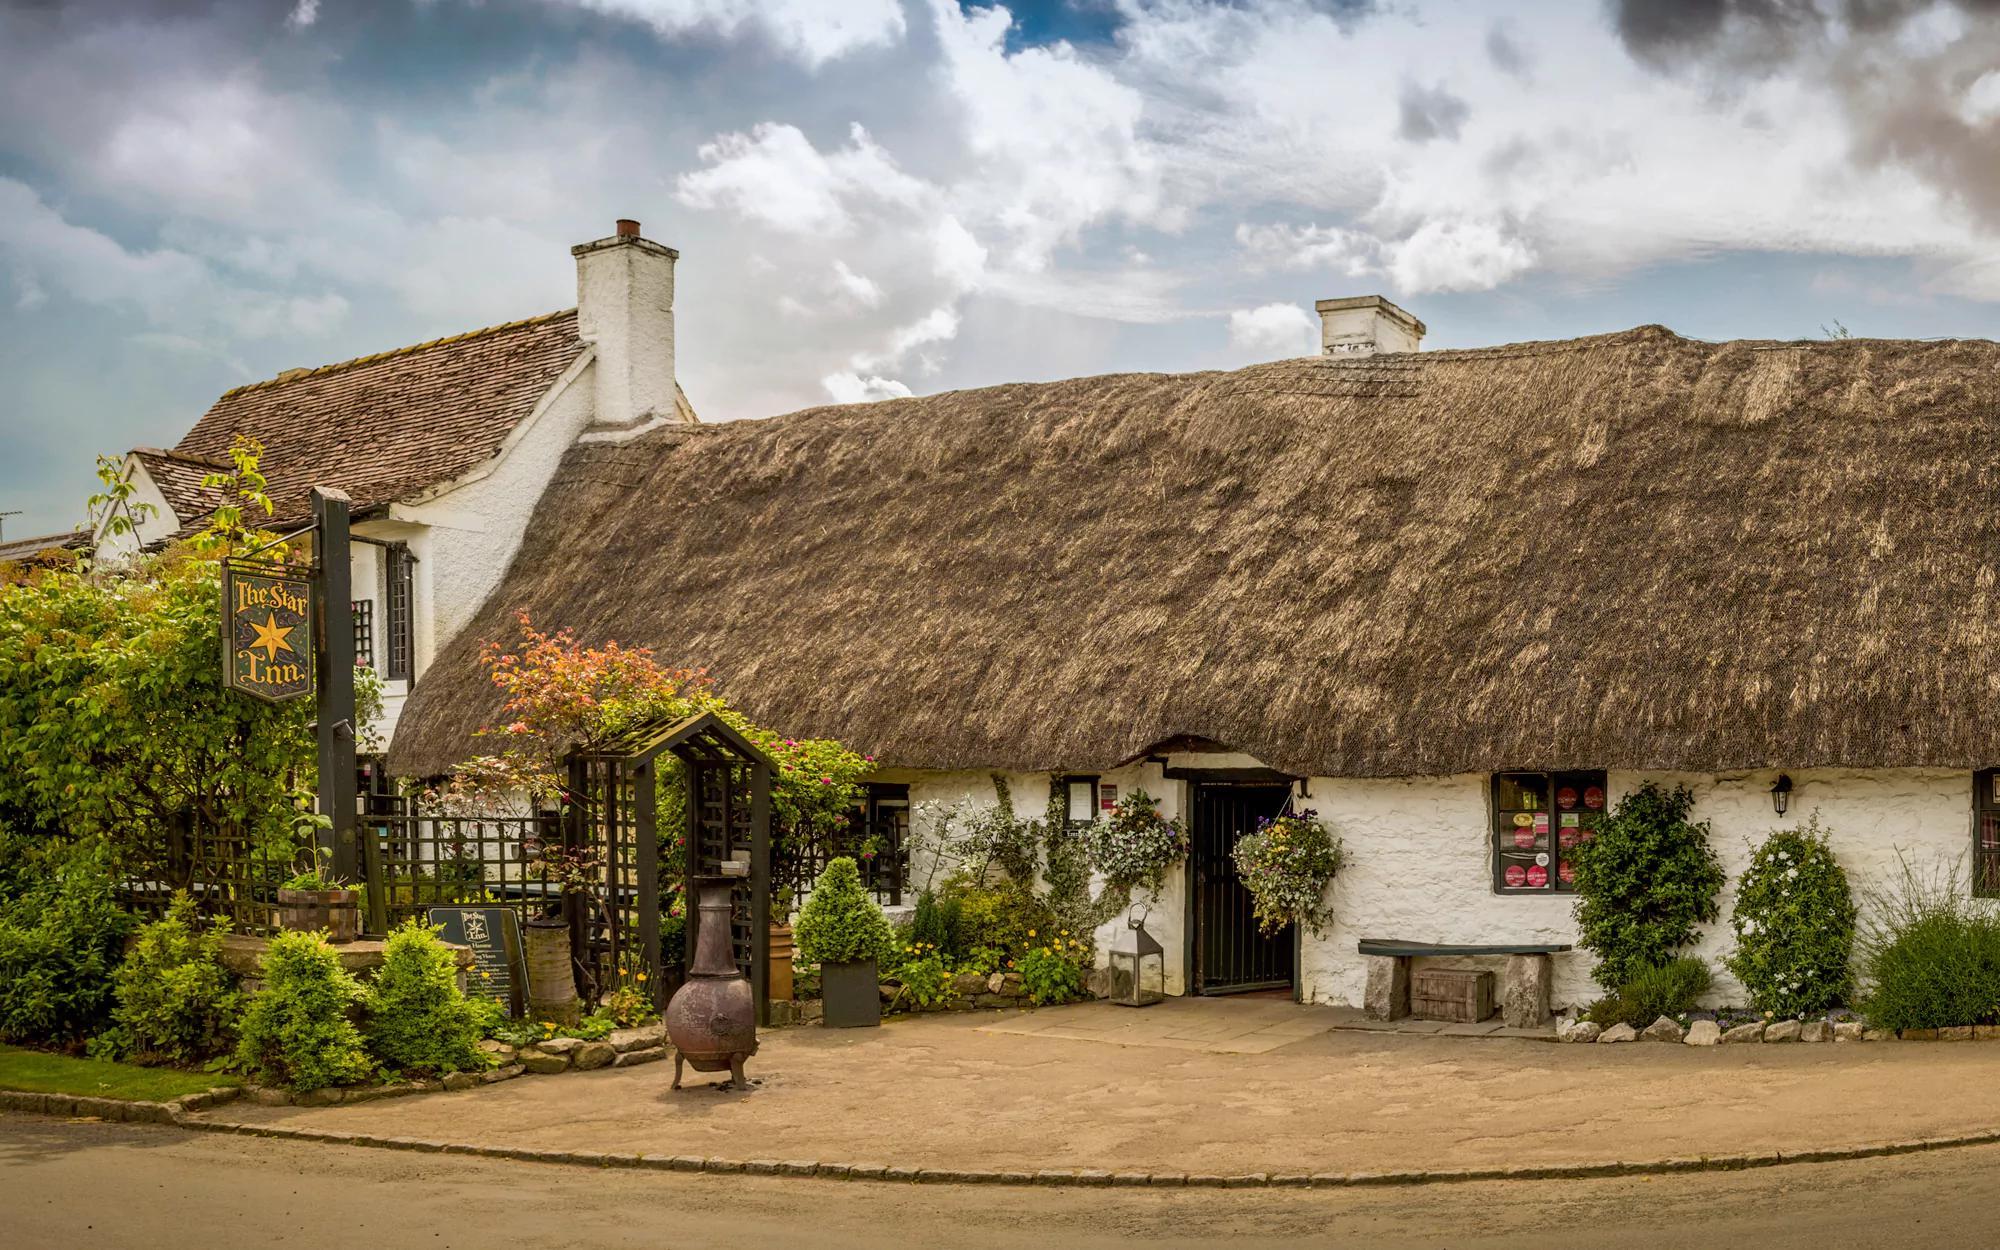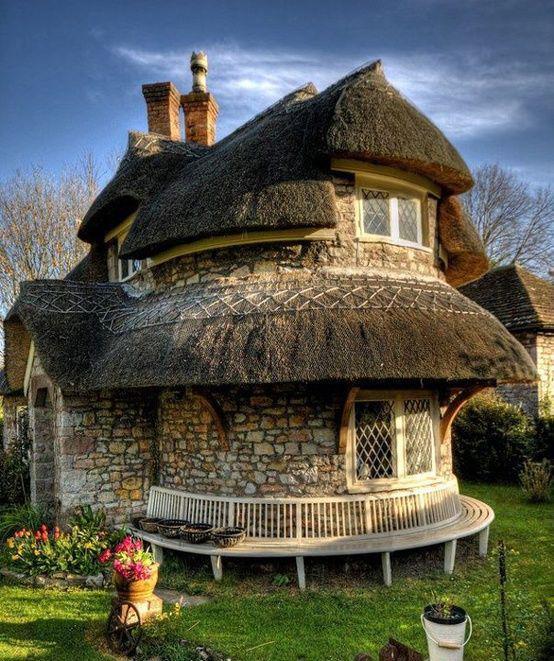The first image is the image on the left, the second image is the image on the right. Analyze the images presented: Is the assertion "An image shows the front of a white house with bold dark lines on it forming geometric patterns, a chimney at at least one end, and a thick gray roof with at least one notched cut-out for windows." valid? Answer yes or no. No. The first image is the image on the left, the second image is the image on the right. Assess this claim about the two images: "There are three windows around the black door of the white house.". Correct or not? Answer yes or no. No. 